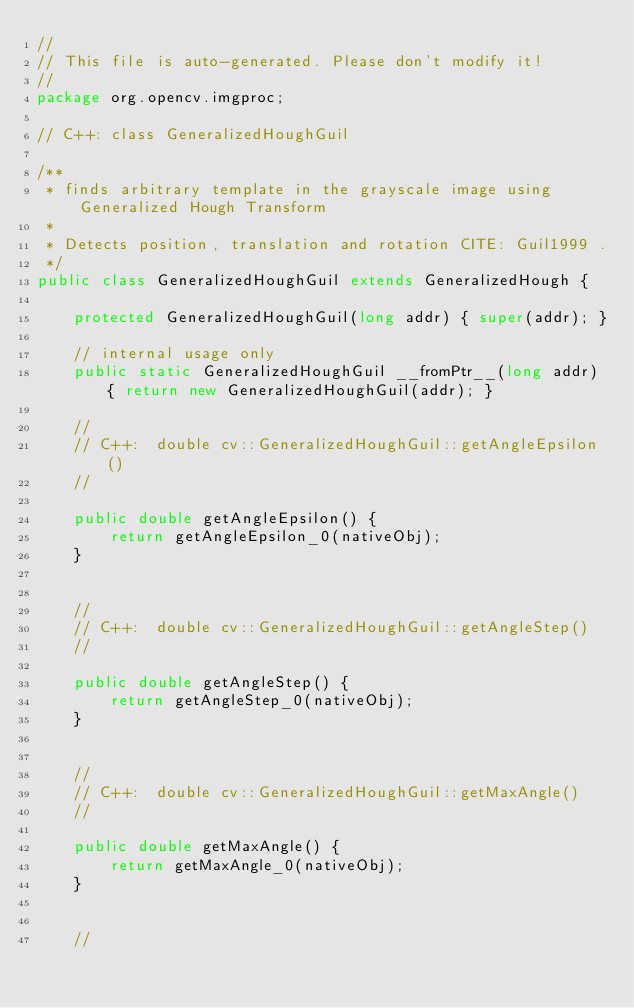Convert code to text. <code><loc_0><loc_0><loc_500><loc_500><_Java_>//
// This file is auto-generated. Please don't modify it!
//
package org.opencv.imgproc;

// C++: class GeneralizedHoughGuil

/**
 * finds arbitrary template in the grayscale image using Generalized Hough Transform
 *
 * Detects position, translation and rotation CITE: Guil1999 .
 */
public class GeneralizedHoughGuil extends GeneralizedHough {

    protected GeneralizedHoughGuil(long addr) { super(addr); }

    // internal usage only
    public static GeneralizedHoughGuil __fromPtr__(long addr) { return new GeneralizedHoughGuil(addr); }

    //
    // C++:  double cv::GeneralizedHoughGuil::getAngleEpsilon()
    //

    public double getAngleEpsilon() {
        return getAngleEpsilon_0(nativeObj);
    }


    //
    // C++:  double cv::GeneralizedHoughGuil::getAngleStep()
    //

    public double getAngleStep() {
        return getAngleStep_0(nativeObj);
    }


    //
    // C++:  double cv::GeneralizedHoughGuil::getMaxAngle()
    //

    public double getMaxAngle() {
        return getMaxAngle_0(nativeObj);
    }


    //</code> 